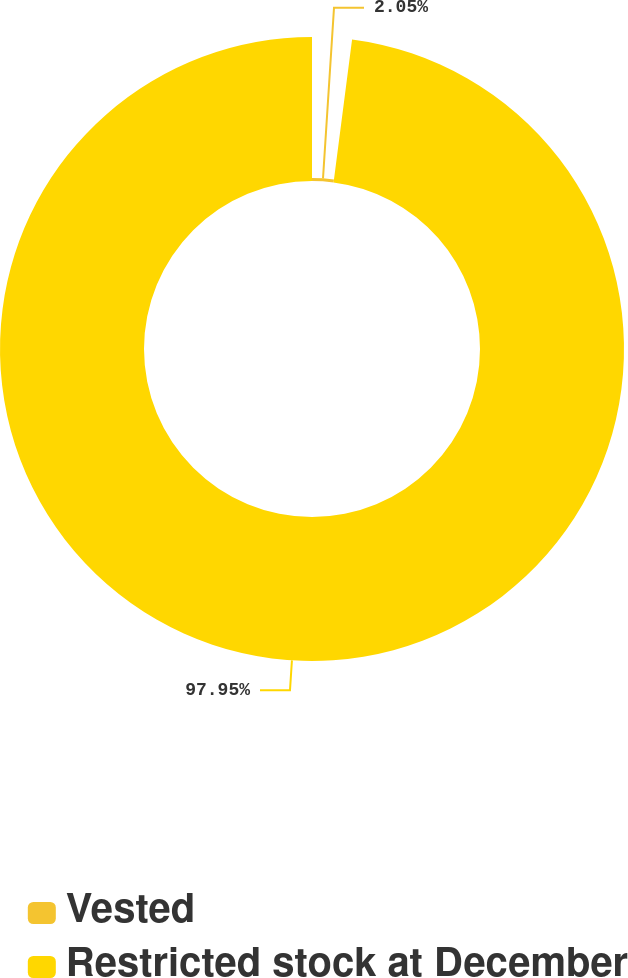<chart> <loc_0><loc_0><loc_500><loc_500><pie_chart><fcel>Vested<fcel>Restricted stock at December<nl><fcel>2.05%<fcel>97.95%<nl></chart> 